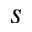Convert formula to latex. <formula><loc_0><loc_0><loc_500><loc_500>s</formula> 